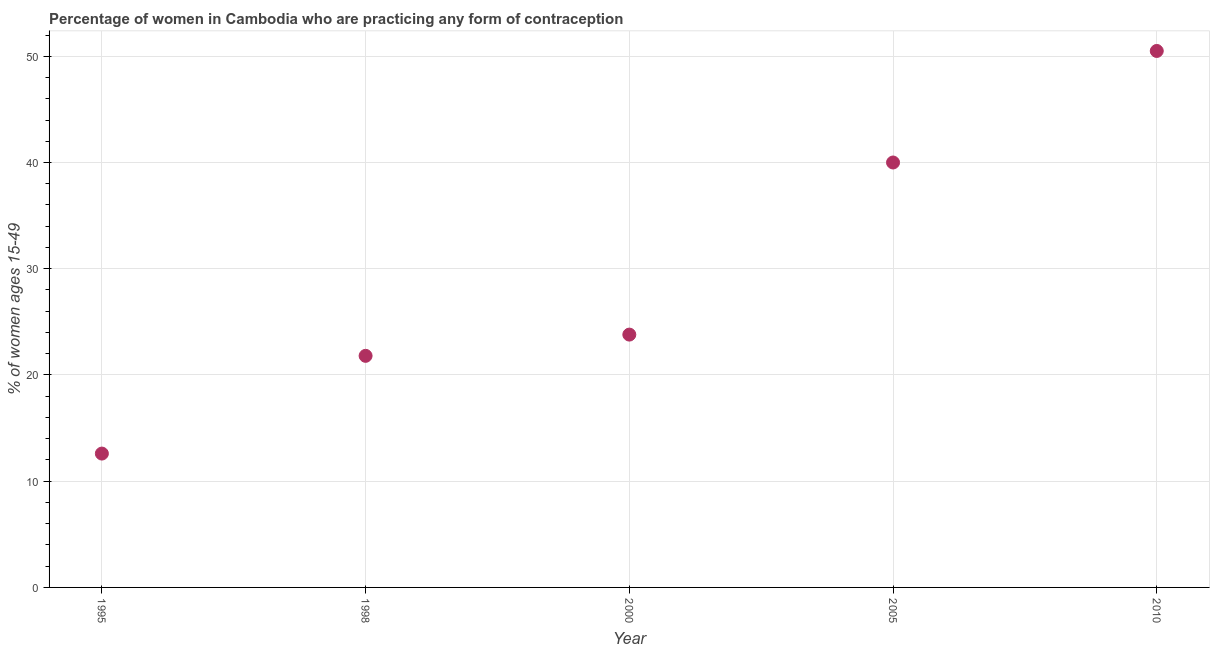Across all years, what is the maximum contraceptive prevalence?
Provide a succinct answer. 50.5. In which year was the contraceptive prevalence maximum?
Offer a terse response. 2010. In which year was the contraceptive prevalence minimum?
Your response must be concise. 1995. What is the sum of the contraceptive prevalence?
Provide a succinct answer. 148.7. What is the difference between the contraceptive prevalence in 1995 and 2005?
Keep it short and to the point. -27.4. What is the average contraceptive prevalence per year?
Your answer should be very brief. 29.74. What is the median contraceptive prevalence?
Your answer should be very brief. 23.8. Do a majority of the years between 1995 and 1998 (inclusive) have contraceptive prevalence greater than 20 %?
Give a very brief answer. No. What is the ratio of the contraceptive prevalence in 1998 to that in 2005?
Keep it short and to the point. 0.55. Is the contraceptive prevalence in 1995 less than that in 2000?
Offer a terse response. Yes. Is the difference between the contraceptive prevalence in 1995 and 2000 greater than the difference between any two years?
Your answer should be compact. No. Is the sum of the contraceptive prevalence in 1995 and 1998 greater than the maximum contraceptive prevalence across all years?
Your response must be concise. No. What is the difference between the highest and the lowest contraceptive prevalence?
Your response must be concise. 37.9. In how many years, is the contraceptive prevalence greater than the average contraceptive prevalence taken over all years?
Your answer should be very brief. 2. Does the contraceptive prevalence monotonically increase over the years?
Provide a short and direct response. Yes. How many dotlines are there?
Offer a very short reply. 1. Are the values on the major ticks of Y-axis written in scientific E-notation?
Your answer should be compact. No. Does the graph contain grids?
Offer a very short reply. Yes. What is the title of the graph?
Your answer should be very brief. Percentage of women in Cambodia who are practicing any form of contraception. What is the label or title of the X-axis?
Ensure brevity in your answer.  Year. What is the label or title of the Y-axis?
Give a very brief answer. % of women ages 15-49. What is the % of women ages 15-49 in 1998?
Your answer should be very brief. 21.8. What is the % of women ages 15-49 in 2000?
Offer a very short reply. 23.8. What is the % of women ages 15-49 in 2010?
Give a very brief answer. 50.5. What is the difference between the % of women ages 15-49 in 1995 and 1998?
Offer a very short reply. -9.2. What is the difference between the % of women ages 15-49 in 1995 and 2000?
Offer a terse response. -11.2. What is the difference between the % of women ages 15-49 in 1995 and 2005?
Offer a very short reply. -27.4. What is the difference between the % of women ages 15-49 in 1995 and 2010?
Offer a terse response. -37.9. What is the difference between the % of women ages 15-49 in 1998 and 2000?
Keep it short and to the point. -2. What is the difference between the % of women ages 15-49 in 1998 and 2005?
Provide a short and direct response. -18.2. What is the difference between the % of women ages 15-49 in 1998 and 2010?
Keep it short and to the point. -28.7. What is the difference between the % of women ages 15-49 in 2000 and 2005?
Ensure brevity in your answer.  -16.2. What is the difference between the % of women ages 15-49 in 2000 and 2010?
Provide a short and direct response. -26.7. What is the ratio of the % of women ages 15-49 in 1995 to that in 1998?
Your response must be concise. 0.58. What is the ratio of the % of women ages 15-49 in 1995 to that in 2000?
Provide a short and direct response. 0.53. What is the ratio of the % of women ages 15-49 in 1995 to that in 2005?
Offer a very short reply. 0.32. What is the ratio of the % of women ages 15-49 in 1995 to that in 2010?
Provide a succinct answer. 0.25. What is the ratio of the % of women ages 15-49 in 1998 to that in 2000?
Offer a terse response. 0.92. What is the ratio of the % of women ages 15-49 in 1998 to that in 2005?
Provide a succinct answer. 0.55. What is the ratio of the % of women ages 15-49 in 1998 to that in 2010?
Keep it short and to the point. 0.43. What is the ratio of the % of women ages 15-49 in 2000 to that in 2005?
Your answer should be compact. 0.59. What is the ratio of the % of women ages 15-49 in 2000 to that in 2010?
Your answer should be very brief. 0.47. What is the ratio of the % of women ages 15-49 in 2005 to that in 2010?
Give a very brief answer. 0.79. 